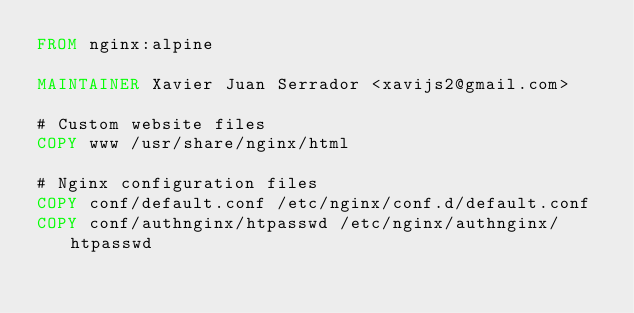Convert code to text. <code><loc_0><loc_0><loc_500><loc_500><_Dockerfile_>FROM nginx:alpine

MAINTAINER Xavier Juan Serrador <xavijs2@gmail.com>

# Custom website files
COPY www /usr/share/nginx/html

# Nginx configuration files
COPY conf/default.conf /etc/nginx/conf.d/default.conf
COPY conf/authnginx/htpasswd /etc/nginx/authnginx/htpasswd
</code> 